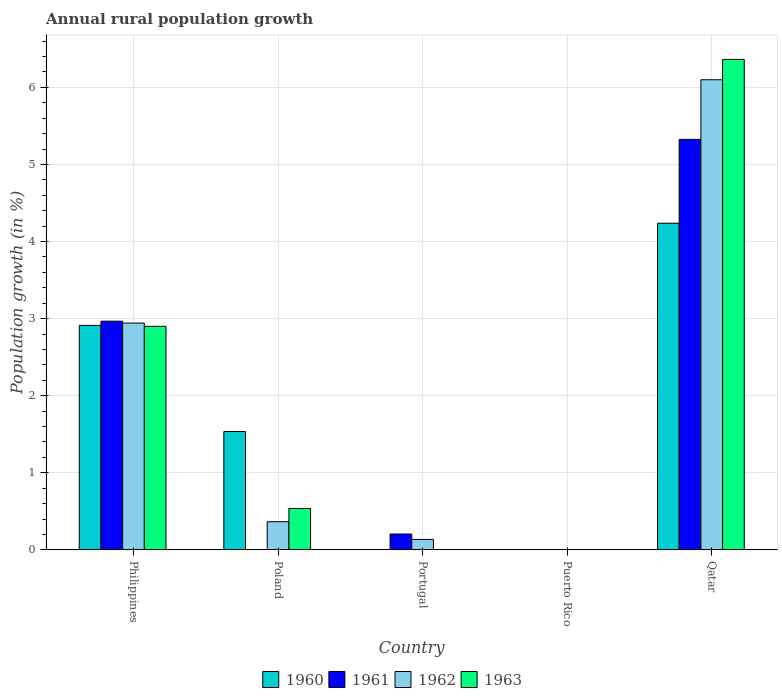Are the number of bars per tick equal to the number of legend labels?
Your answer should be very brief. No. How many bars are there on the 1st tick from the right?
Offer a very short reply. 4. What is the label of the 3rd group of bars from the left?
Make the answer very short. Portugal. In how many cases, is the number of bars for a given country not equal to the number of legend labels?
Keep it short and to the point. 3. What is the percentage of rural population growth in 1962 in Portugal?
Keep it short and to the point. 0.14. Across all countries, what is the maximum percentage of rural population growth in 1962?
Keep it short and to the point. 6.1. Across all countries, what is the minimum percentage of rural population growth in 1962?
Provide a succinct answer. 0. In which country was the percentage of rural population growth in 1961 maximum?
Offer a terse response. Qatar. What is the total percentage of rural population growth in 1963 in the graph?
Offer a terse response. 9.8. What is the difference between the percentage of rural population growth in 1961 in Philippines and that in Portugal?
Offer a very short reply. 2.76. What is the difference between the percentage of rural population growth in 1963 in Poland and the percentage of rural population growth in 1961 in Qatar?
Offer a terse response. -4.79. What is the average percentage of rural population growth in 1962 per country?
Your answer should be very brief. 1.91. What is the difference between the percentage of rural population growth of/in 1963 and percentage of rural population growth of/in 1960 in Qatar?
Provide a succinct answer. 2.13. What is the ratio of the percentage of rural population growth in 1961 in Philippines to that in Portugal?
Ensure brevity in your answer.  14.45. What is the difference between the highest and the second highest percentage of rural population growth in 1963?
Provide a succinct answer. -2.36. What is the difference between the highest and the lowest percentage of rural population growth in 1963?
Provide a short and direct response. 6.36. How many bars are there?
Make the answer very short. 13. Does the graph contain any zero values?
Provide a short and direct response. Yes. How many legend labels are there?
Give a very brief answer. 4. What is the title of the graph?
Provide a succinct answer. Annual rural population growth. Does "1994" appear as one of the legend labels in the graph?
Give a very brief answer. No. What is the label or title of the Y-axis?
Keep it short and to the point. Population growth (in %). What is the Population growth (in %) in 1960 in Philippines?
Provide a short and direct response. 2.91. What is the Population growth (in %) in 1961 in Philippines?
Your answer should be compact. 2.97. What is the Population growth (in %) of 1962 in Philippines?
Ensure brevity in your answer.  2.94. What is the Population growth (in %) in 1963 in Philippines?
Offer a terse response. 2.9. What is the Population growth (in %) of 1960 in Poland?
Your response must be concise. 1.53. What is the Population growth (in %) of 1961 in Poland?
Your answer should be very brief. 0. What is the Population growth (in %) of 1962 in Poland?
Give a very brief answer. 0.36. What is the Population growth (in %) of 1963 in Poland?
Provide a short and direct response. 0.54. What is the Population growth (in %) in 1961 in Portugal?
Your answer should be compact. 0.21. What is the Population growth (in %) in 1962 in Portugal?
Give a very brief answer. 0.14. What is the Population growth (in %) of 1963 in Portugal?
Offer a terse response. 0. What is the Population growth (in %) in 1960 in Puerto Rico?
Give a very brief answer. 0. What is the Population growth (in %) of 1962 in Puerto Rico?
Provide a succinct answer. 0. What is the Population growth (in %) of 1960 in Qatar?
Ensure brevity in your answer.  4.24. What is the Population growth (in %) of 1961 in Qatar?
Keep it short and to the point. 5.33. What is the Population growth (in %) of 1962 in Qatar?
Ensure brevity in your answer.  6.1. What is the Population growth (in %) in 1963 in Qatar?
Your response must be concise. 6.36. Across all countries, what is the maximum Population growth (in %) in 1960?
Ensure brevity in your answer.  4.24. Across all countries, what is the maximum Population growth (in %) in 1961?
Give a very brief answer. 5.33. Across all countries, what is the maximum Population growth (in %) in 1962?
Provide a succinct answer. 6.1. Across all countries, what is the maximum Population growth (in %) in 1963?
Your answer should be very brief. 6.36. Across all countries, what is the minimum Population growth (in %) of 1960?
Give a very brief answer. 0. Across all countries, what is the minimum Population growth (in %) of 1961?
Provide a succinct answer. 0. What is the total Population growth (in %) of 1960 in the graph?
Keep it short and to the point. 8.68. What is the total Population growth (in %) of 1961 in the graph?
Your answer should be very brief. 8.5. What is the total Population growth (in %) in 1962 in the graph?
Provide a short and direct response. 9.54. What is the total Population growth (in %) of 1963 in the graph?
Your answer should be compact. 9.8. What is the difference between the Population growth (in %) of 1960 in Philippines and that in Poland?
Make the answer very short. 1.38. What is the difference between the Population growth (in %) of 1962 in Philippines and that in Poland?
Provide a succinct answer. 2.58. What is the difference between the Population growth (in %) in 1963 in Philippines and that in Poland?
Give a very brief answer. 2.36. What is the difference between the Population growth (in %) in 1961 in Philippines and that in Portugal?
Your answer should be very brief. 2.76. What is the difference between the Population growth (in %) in 1962 in Philippines and that in Portugal?
Offer a very short reply. 2.81. What is the difference between the Population growth (in %) of 1960 in Philippines and that in Qatar?
Make the answer very short. -1.33. What is the difference between the Population growth (in %) of 1961 in Philippines and that in Qatar?
Provide a succinct answer. -2.36. What is the difference between the Population growth (in %) of 1962 in Philippines and that in Qatar?
Make the answer very short. -3.16. What is the difference between the Population growth (in %) in 1963 in Philippines and that in Qatar?
Give a very brief answer. -3.46. What is the difference between the Population growth (in %) of 1962 in Poland and that in Portugal?
Keep it short and to the point. 0.23. What is the difference between the Population growth (in %) of 1960 in Poland and that in Qatar?
Provide a succinct answer. -2.7. What is the difference between the Population growth (in %) in 1962 in Poland and that in Qatar?
Keep it short and to the point. -5.73. What is the difference between the Population growth (in %) of 1963 in Poland and that in Qatar?
Keep it short and to the point. -5.83. What is the difference between the Population growth (in %) of 1961 in Portugal and that in Qatar?
Your answer should be compact. -5.12. What is the difference between the Population growth (in %) of 1962 in Portugal and that in Qatar?
Keep it short and to the point. -5.96. What is the difference between the Population growth (in %) in 1960 in Philippines and the Population growth (in %) in 1962 in Poland?
Make the answer very short. 2.55. What is the difference between the Population growth (in %) of 1960 in Philippines and the Population growth (in %) of 1963 in Poland?
Ensure brevity in your answer.  2.38. What is the difference between the Population growth (in %) in 1961 in Philippines and the Population growth (in %) in 1962 in Poland?
Provide a short and direct response. 2.6. What is the difference between the Population growth (in %) of 1961 in Philippines and the Population growth (in %) of 1963 in Poland?
Your answer should be very brief. 2.43. What is the difference between the Population growth (in %) of 1962 in Philippines and the Population growth (in %) of 1963 in Poland?
Your response must be concise. 2.41. What is the difference between the Population growth (in %) in 1960 in Philippines and the Population growth (in %) in 1961 in Portugal?
Make the answer very short. 2.71. What is the difference between the Population growth (in %) of 1960 in Philippines and the Population growth (in %) of 1962 in Portugal?
Keep it short and to the point. 2.78. What is the difference between the Population growth (in %) of 1961 in Philippines and the Population growth (in %) of 1962 in Portugal?
Offer a terse response. 2.83. What is the difference between the Population growth (in %) in 1960 in Philippines and the Population growth (in %) in 1961 in Qatar?
Your answer should be very brief. -2.41. What is the difference between the Population growth (in %) of 1960 in Philippines and the Population growth (in %) of 1962 in Qatar?
Give a very brief answer. -3.19. What is the difference between the Population growth (in %) in 1960 in Philippines and the Population growth (in %) in 1963 in Qatar?
Ensure brevity in your answer.  -3.45. What is the difference between the Population growth (in %) in 1961 in Philippines and the Population growth (in %) in 1962 in Qatar?
Offer a very short reply. -3.13. What is the difference between the Population growth (in %) in 1961 in Philippines and the Population growth (in %) in 1963 in Qatar?
Give a very brief answer. -3.4. What is the difference between the Population growth (in %) in 1962 in Philippines and the Population growth (in %) in 1963 in Qatar?
Your response must be concise. -3.42. What is the difference between the Population growth (in %) of 1960 in Poland and the Population growth (in %) of 1961 in Portugal?
Give a very brief answer. 1.33. What is the difference between the Population growth (in %) of 1960 in Poland and the Population growth (in %) of 1962 in Portugal?
Your answer should be very brief. 1.4. What is the difference between the Population growth (in %) of 1960 in Poland and the Population growth (in %) of 1961 in Qatar?
Offer a very short reply. -3.79. What is the difference between the Population growth (in %) in 1960 in Poland and the Population growth (in %) in 1962 in Qatar?
Provide a short and direct response. -4.56. What is the difference between the Population growth (in %) in 1960 in Poland and the Population growth (in %) in 1963 in Qatar?
Give a very brief answer. -4.83. What is the difference between the Population growth (in %) in 1962 in Poland and the Population growth (in %) in 1963 in Qatar?
Make the answer very short. -6. What is the difference between the Population growth (in %) in 1961 in Portugal and the Population growth (in %) in 1962 in Qatar?
Make the answer very short. -5.89. What is the difference between the Population growth (in %) in 1961 in Portugal and the Population growth (in %) in 1963 in Qatar?
Ensure brevity in your answer.  -6.16. What is the difference between the Population growth (in %) of 1962 in Portugal and the Population growth (in %) of 1963 in Qatar?
Give a very brief answer. -6.23. What is the average Population growth (in %) of 1960 per country?
Your response must be concise. 1.74. What is the average Population growth (in %) in 1961 per country?
Offer a terse response. 1.7. What is the average Population growth (in %) of 1962 per country?
Ensure brevity in your answer.  1.91. What is the average Population growth (in %) in 1963 per country?
Keep it short and to the point. 1.96. What is the difference between the Population growth (in %) of 1960 and Population growth (in %) of 1961 in Philippines?
Ensure brevity in your answer.  -0.05. What is the difference between the Population growth (in %) in 1960 and Population growth (in %) in 1962 in Philippines?
Offer a very short reply. -0.03. What is the difference between the Population growth (in %) of 1960 and Population growth (in %) of 1963 in Philippines?
Your answer should be compact. 0.01. What is the difference between the Population growth (in %) of 1961 and Population growth (in %) of 1962 in Philippines?
Ensure brevity in your answer.  0.02. What is the difference between the Population growth (in %) in 1961 and Population growth (in %) in 1963 in Philippines?
Provide a succinct answer. 0.07. What is the difference between the Population growth (in %) of 1962 and Population growth (in %) of 1963 in Philippines?
Offer a terse response. 0.04. What is the difference between the Population growth (in %) in 1960 and Population growth (in %) in 1962 in Poland?
Offer a terse response. 1.17. What is the difference between the Population growth (in %) in 1960 and Population growth (in %) in 1963 in Poland?
Provide a succinct answer. 1. What is the difference between the Population growth (in %) of 1962 and Population growth (in %) of 1963 in Poland?
Ensure brevity in your answer.  -0.17. What is the difference between the Population growth (in %) in 1961 and Population growth (in %) in 1962 in Portugal?
Give a very brief answer. 0.07. What is the difference between the Population growth (in %) in 1960 and Population growth (in %) in 1961 in Qatar?
Provide a short and direct response. -1.09. What is the difference between the Population growth (in %) in 1960 and Population growth (in %) in 1962 in Qatar?
Make the answer very short. -1.86. What is the difference between the Population growth (in %) in 1960 and Population growth (in %) in 1963 in Qatar?
Keep it short and to the point. -2.13. What is the difference between the Population growth (in %) of 1961 and Population growth (in %) of 1962 in Qatar?
Give a very brief answer. -0.77. What is the difference between the Population growth (in %) of 1961 and Population growth (in %) of 1963 in Qatar?
Ensure brevity in your answer.  -1.04. What is the difference between the Population growth (in %) of 1962 and Population growth (in %) of 1963 in Qatar?
Your answer should be compact. -0.26. What is the ratio of the Population growth (in %) in 1960 in Philippines to that in Poland?
Provide a succinct answer. 1.9. What is the ratio of the Population growth (in %) of 1962 in Philippines to that in Poland?
Provide a succinct answer. 8.06. What is the ratio of the Population growth (in %) in 1963 in Philippines to that in Poland?
Provide a succinct answer. 5.41. What is the ratio of the Population growth (in %) in 1961 in Philippines to that in Portugal?
Your answer should be very brief. 14.45. What is the ratio of the Population growth (in %) of 1962 in Philippines to that in Portugal?
Your response must be concise. 21.75. What is the ratio of the Population growth (in %) of 1960 in Philippines to that in Qatar?
Provide a short and direct response. 0.69. What is the ratio of the Population growth (in %) of 1961 in Philippines to that in Qatar?
Give a very brief answer. 0.56. What is the ratio of the Population growth (in %) in 1962 in Philippines to that in Qatar?
Make the answer very short. 0.48. What is the ratio of the Population growth (in %) of 1963 in Philippines to that in Qatar?
Keep it short and to the point. 0.46. What is the ratio of the Population growth (in %) of 1962 in Poland to that in Portugal?
Keep it short and to the point. 2.7. What is the ratio of the Population growth (in %) in 1960 in Poland to that in Qatar?
Your response must be concise. 0.36. What is the ratio of the Population growth (in %) in 1962 in Poland to that in Qatar?
Your answer should be very brief. 0.06. What is the ratio of the Population growth (in %) in 1963 in Poland to that in Qatar?
Your answer should be very brief. 0.08. What is the ratio of the Population growth (in %) in 1961 in Portugal to that in Qatar?
Provide a short and direct response. 0.04. What is the ratio of the Population growth (in %) in 1962 in Portugal to that in Qatar?
Give a very brief answer. 0.02. What is the difference between the highest and the second highest Population growth (in %) in 1960?
Your answer should be very brief. 1.33. What is the difference between the highest and the second highest Population growth (in %) in 1961?
Give a very brief answer. 2.36. What is the difference between the highest and the second highest Population growth (in %) of 1962?
Keep it short and to the point. 3.16. What is the difference between the highest and the second highest Population growth (in %) in 1963?
Your response must be concise. 3.46. What is the difference between the highest and the lowest Population growth (in %) of 1960?
Give a very brief answer. 4.24. What is the difference between the highest and the lowest Population growth (in %) of 1961?
Make the answer very short. 5.33. What is the difference between the highest and the lowest Population growth (in %) in 1962?
Give a very brief answer. 6.1. What is the difference between the highest and the lowest Population growth (in %) in 1963?
Provide a short and direct response. 6.36. 